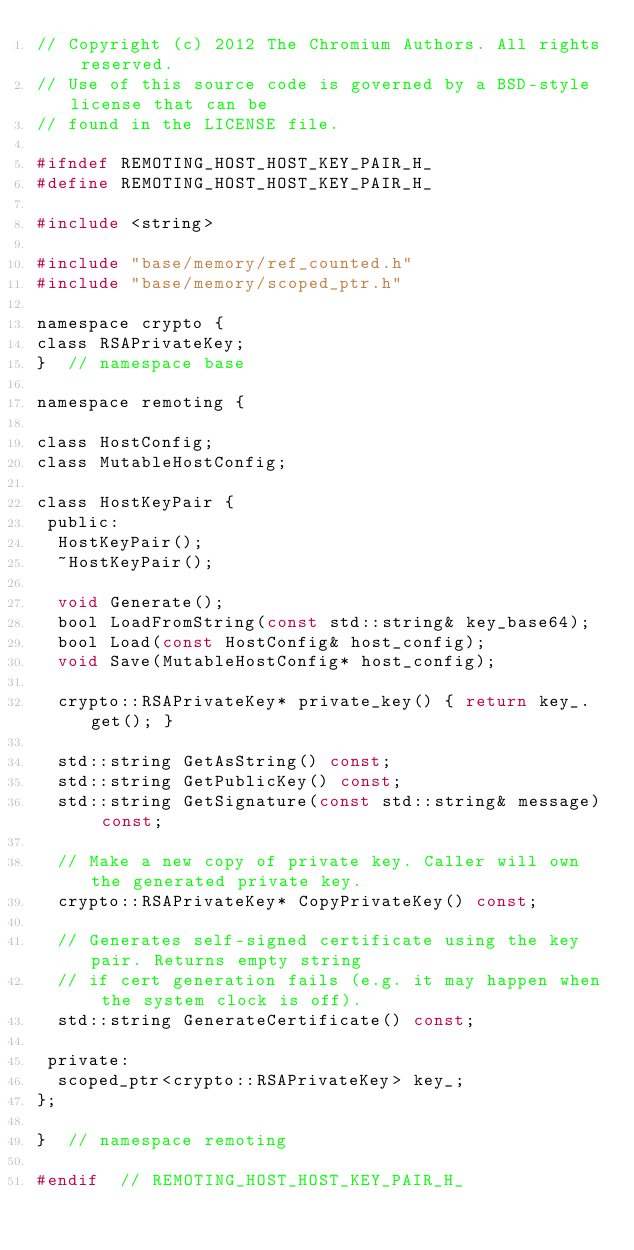<code> <loc_0><loc_0><loc_500><loc_500><_C_>// Copyright (c) 2012 The Chromium Authors. All rights reserved.
// Use of this source code is governed by a BSD-style license that can be
// found in the LICENSE file.

#ifndef REMOTING_HOST_HOST_KEY_PAIR_H_
#define REMOTING_HOST_HOST_KEY_PAIR_H_

#include <string>

#include "base/memory/ref_counted.h"
#include "base/memory/scoped_ptr.h"

namespace crypto {
class RSAPrivateKey;
}  // namespace base

namespace remoting {

class HostConfig;
class MutableHostConfig;

class HostKeyPair {
 public:
  HostKeyPair();
  ~HostKeyPair();

  void Generate();
  bool LoadFromString(const std::string& key_base64);
  bool Load(const HostConfig& host_config);
  void Save(MutableHostConfig* host_config);

  crypto::RSAPrivateKey* private_key() { return key_.get(); }

  std::string GetAsString() const;
  std::string GetPublicKey() const;
  std::string GetSignature(const std::string& message) const;

  // Make a new copy of private key. Caller will own the generated private key.
  crypto::RSAPrivateKey* CopyPrivateKey() const;

  // Generates self-signed certificate using the key pair. Returns empty string
  // if cert generation fails (e.g. it may happen when the system clock is off).
  std::string GenerateCertificate() const;

 private:
  scoped_ptr<crypto::RSAPrivateKey> key_;
};

}  // namespace remoting

#endif  // REMOTING_HOST_HOST_KEY_PAIR_H_
</code> 